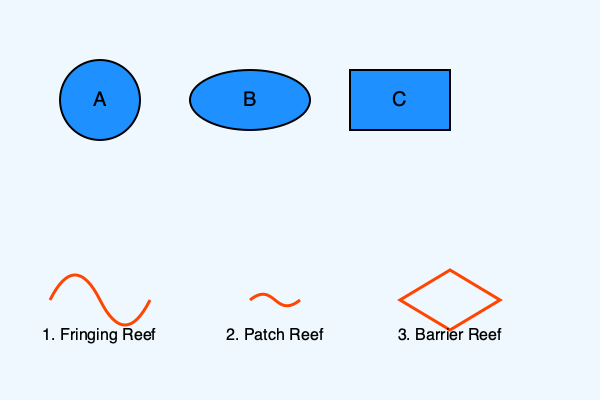Match the aerial views (A, B, C) with their corresponding coral reef formations (1, 2, 3). Which combination is correct? To match the aerial views with their corresponding coral reef formations, we need to analyze the shapes and characteristics of each:

1. Aerial view A shows a circular shape. This is most consistent with a patch reef, which typically appears as isolated, roughly circular reef formations when viewed from above.

2. Aerial view B displays an elongated elliptical shape. This is characteristic of a fringing reef, which forms along the coastline and often appears as a long, narrow band when viewed from above.

3. Aerial view C shows a rectangular shape with clear, straight edges. This is most likely to represent a barrier reef, which forms parallel to the coastline but at a greater distance, often appearing as a more linear and extensive formation.

Matching these characteristics:
A corresponds to 2 (Patch Reef)
B corresponds to 1 (Fringing Reef)
C corresponds to 3 (Barrier Reef)

Therefore, the correct combination is A2, B1, C3.
Answer: A2, B1, C3 